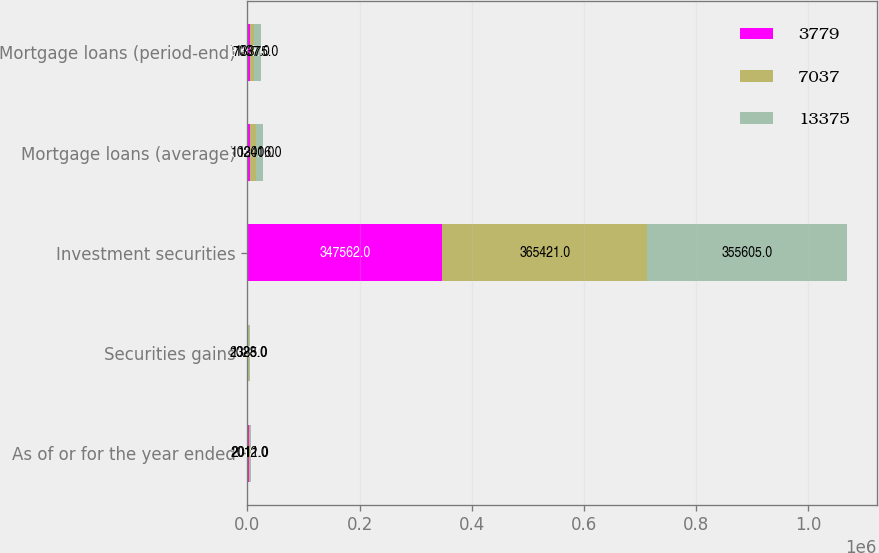Convert chart. <chart><loc_0><loc_0><loc_500><loc_500><stacked_bar_chart><ecel><fcel>As of or for the year ended<fcel>Securities gains<fcel>Investment securities<fcel>Mortgage loans (average)<fcel>Mortgage loans (period-end)<nl><fcel>3779<fcel>2013<fcel>659<fcel>347562<fcel>5145<fcel>3779<nl><fcel>7037<fcel>2012<fcel>2028<fcel>365421<fcel>10241<fcel>7037<nl><fcel>13375<fcel>2011<fcel>1385<fcel>355605<fcel>13006<fcel>13375<nl></chart> 